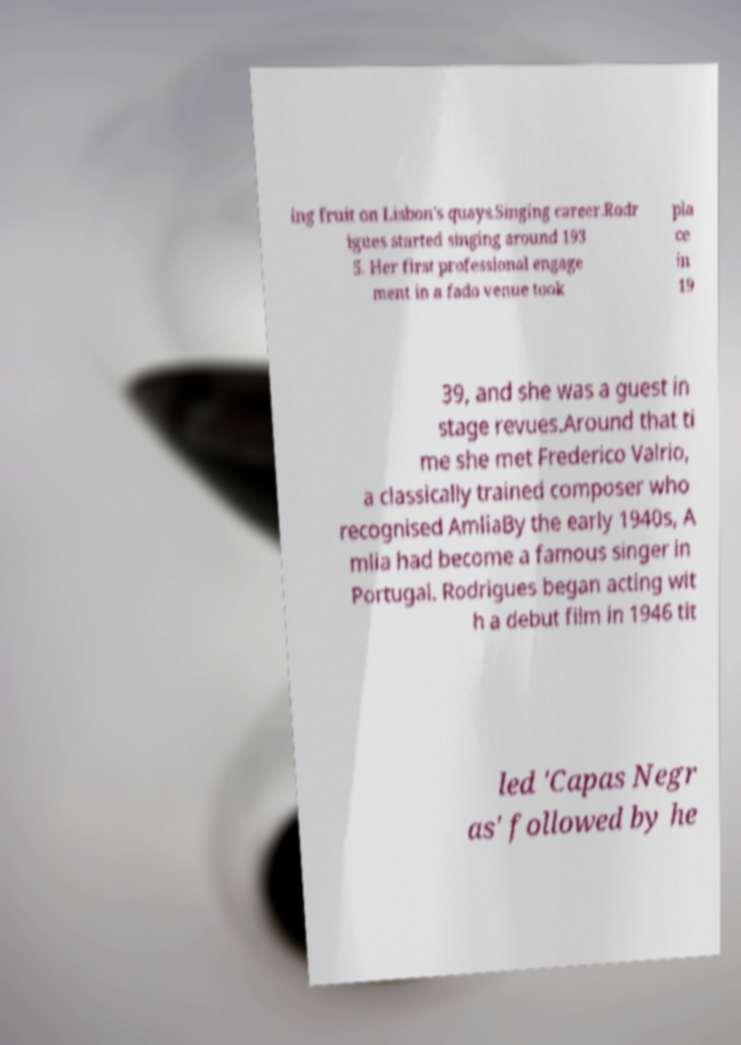Can you accurately transcribe the text from the provided image for me? ing fruit on Lisbon's quays.Singing career.Rodr igues started singing around 193 5. Her first professional engage ment in a fado venue took pla ce in 19 39, and she was a guest in stage revues.Around that ti me she met Frederico Valrio, a classically trained composer who recognised AmliaBy the early 1940s, A mlia had become a famous singer in Portugal. Rodrigues began acting wit h a debut film in 1946 tit led 'Capas Negr as' followed by he 